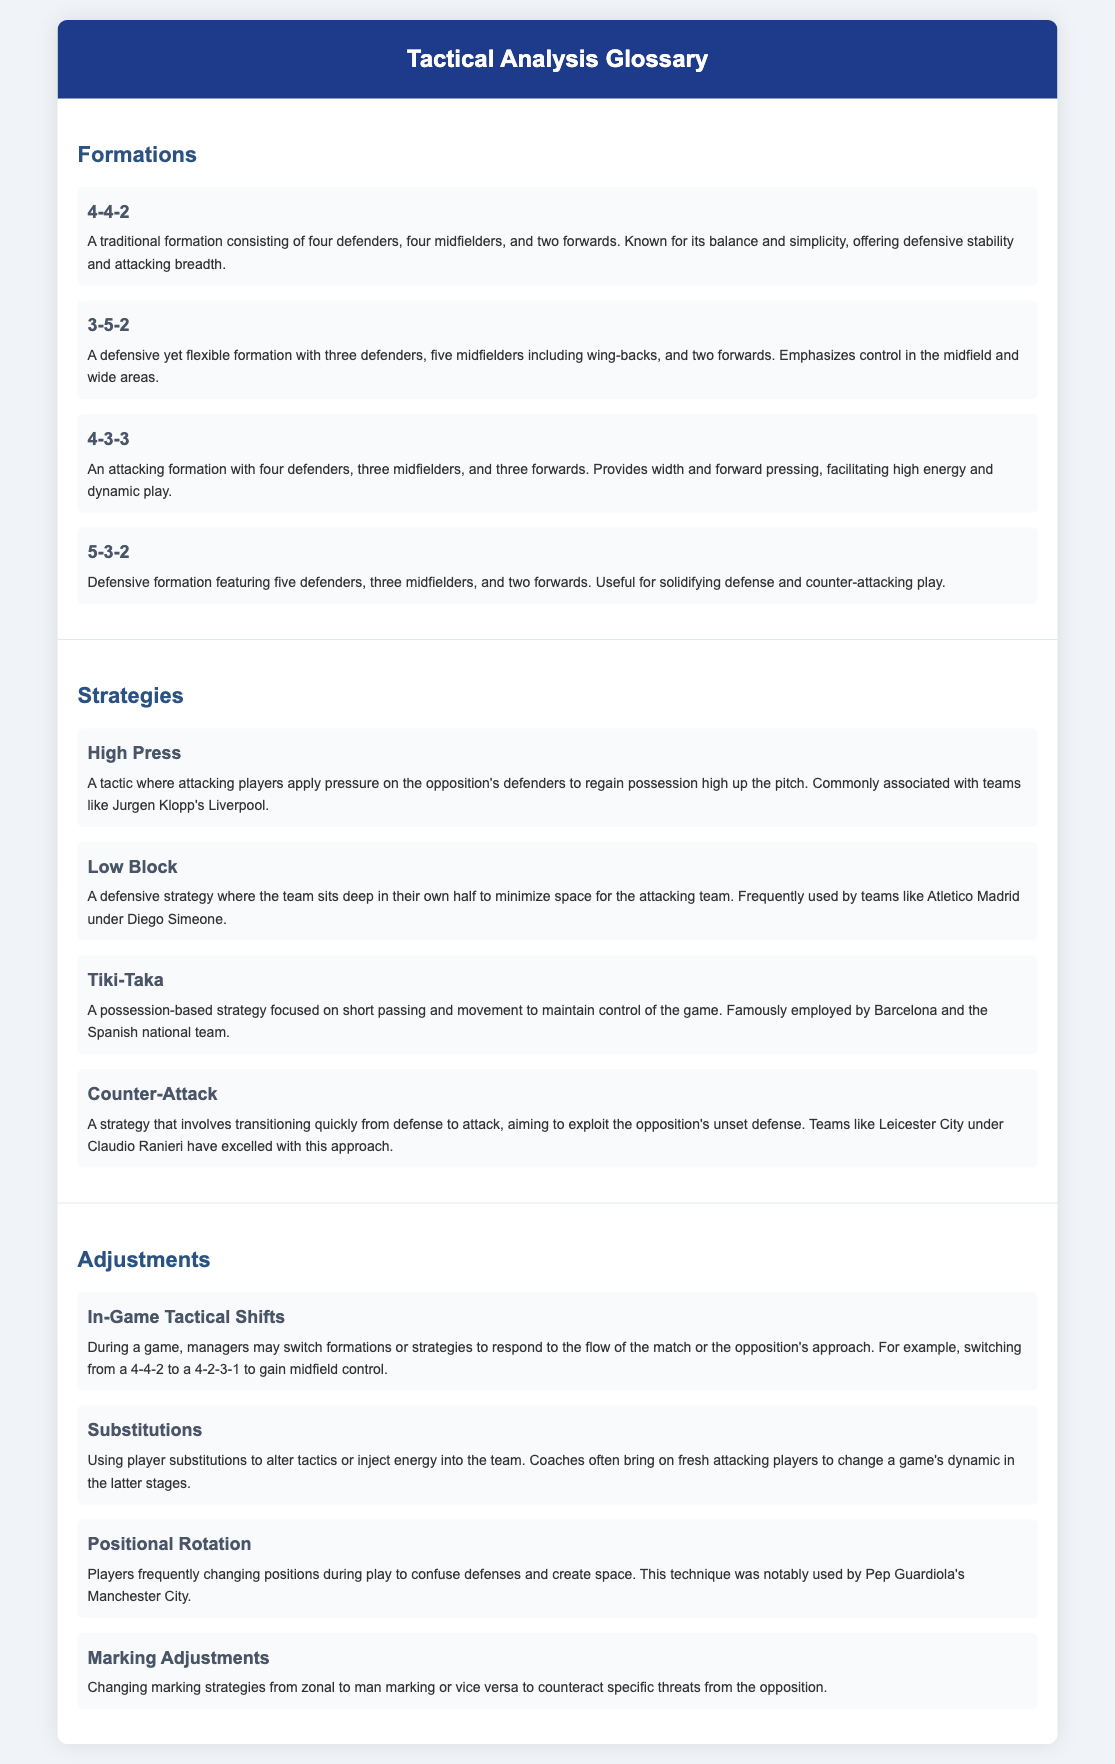What is the formation with four defenders and three midfielders? The document lists the 4-3-3 formation under Formations, which consists of four defenders and three midfielders.
Answer: 4-3-3 Which team is commonly associated with the High Press tactic? The document mentions that the High Press is commonly associated with teams like Jurgen Klopp's Liverpool.
Answer: Liverpool What is the defensive strategy where teams sit deep in their own half called? The document refers to this defensive strategy as the Low Block.
Answer: Low Block How many forwards are in the 5-3-2 formation? The document states that the 5-3-2 formation features two forwards.
Answer: 2 What is a tactic that involves quick transitions from defense to attack? The document describes this tactic as Counter-Attack.
Answer: Counter-Attack What is the purpose of players frequently changing positions during play? The document states that this is done to confuse defenses and create space.
Answer: Confuse defenses What is the term for switching formations during a game? The document refers to this as In-Game Tactical Shifts.
Answer: In-Game Tactical Shifts What type of adjustments involve bringing on fresh players? The document describes these adjustments as Substitutions.
Answer: Substitutions How many defenders are in the 3-5-2 formation? The document outlines that the 3-5-2 formation consists of three defenders.
Answer: 3 